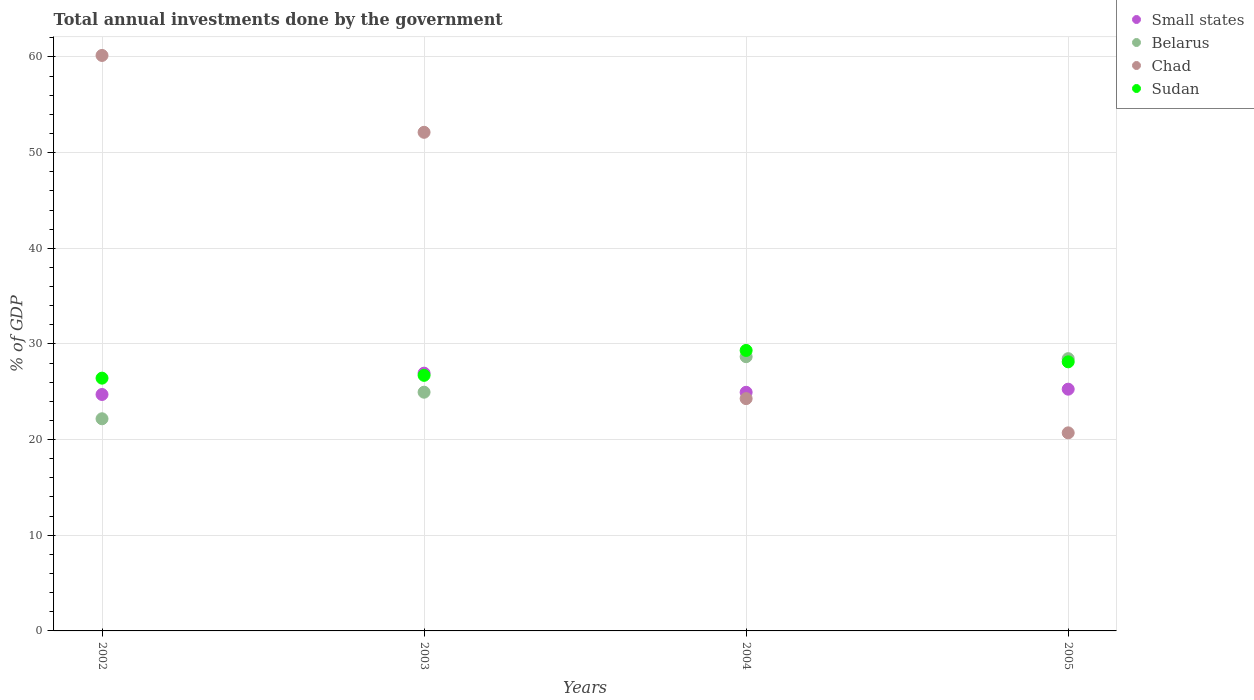How many different coloured dotlines are there?
Give a very brief answer. 4. What is the total annual investments done by the government in Chad in 2005?
Make the answer very short. 20.7. Across all years, what is the maximum total annual investments done by the government in Small states?
Offer a very short reply. 26.95. Across all years, what is the minimum total annual investments done by the government in Belarus?
Offer a very short reply. 22.18. In which year was the total annual investments done by the government in Small states minimum?
Keep it short and to the point. 2002. What is the total total annual investments done by the government in Small states in the graph?
Make the answer very short. 101.88. What is the difference between the total annual investments done by the government in Sudan in 2002 and that in 2004?
Provide a succinct answer. -2.9. What is the difference between the total annual investments done by the government in Chad in 2002 and the total annual investments done by the government in Sudan in 2003?
Provide a short and direct response. 33.44. What is the average total annual investments done by the government in Small states per year?
Provide a short and direct response. 25.47. In the year 2004, what is the difference between the total annual investments done by the government in Chad and total annual investments done by the government in Sudan?
Ensure brevity in your answer.  -5.04. In how many years, is the total annual investments done by the government in Chad greater than 44 %?
Provide a succinct answer. 2. What is the ratio of the total annual investments done by the government in Chad in 2002 to that in 2005?
Make the answer very short. 2.91. What is the difference between the highest and the second highest total annual investments done by the government in Small states?
Ensure brevity in your answer.  1.67. What is the difference between the highest and the lowest total annual investments done by the government in Chad?
Give a very brief answer. 39.45. Is the sum of the total annual investments done by the government in Belarus in 2002 and 2005 greater than the maximum total annual investments done by the government in Chad across all years?
Give a very brief answer. No. Does the total annual investments done by the government in Belarus monotonically increase over the years?
Make the answer very short. No. Is the total annual investments done by the government in Chad strictly greater than the total annual investments done by the government in Belarus over the years?
Keep it short and to the point. No. How many dotlines are there?
Keep it short and to the point. 4. Are the values on the major ticks of Y-axis written in scientific E-notation?
Offer a terse response. No. Does the graph contain grids?
Offer a very short reply. Yes. How many legend labels are there?
Your answer should be compact. 4. How are the legend labels stacked?
Offer a very short reply. Vertical. What is the title of the graph?
Give a very brief answer. Total annual investments done by the government. What is the label or title of the Y-axis?
Offer a very short reply. % of GDP. What is the % of GDP in Small states in 2002?
Ensure brevity in your answer.  24.72. What is the % of GDP in Belarus in 2002?
Provide a short and direct response. 22.18. What is the % of GDP of Chad in 2002?
Offer a terse response. 60.16. What is the % of GDP in Sudan in 2002?
Make the answer very short. 26.42. What is the % of GDP in Small states in 2003?
Provide a short and direct response. 26.95. What is the % of GDP of Belarus in 2003?
Ensure brevity in your answer.  24.95. What is the % of GDP in Chad in 2003?
Offer a terse response. 52.12. What is the % of GDP in Sudan in 2003?
Provide a short and direct response. 26.71. What is the % of GDP in Small states in 2004?
Give a very brief answer. 24.94. What is the % of GDP in Belarus in 2004?
Your answer should be compact. 28.67. What is the % of GDP of Chad in 2004?
Make the answer very short. 24.28. What is the % of GDP of Sudan in 2004?
Your answer should be compact. 29.32. What is the % of GDP of Small states in 2005?
Keep it short and to the point. 25.27. What is the % of GDP in Belarus in 2005?
Give a very brief answer. 28.46. What is the % of GDP of Chad in 2005?
Your response must be concise. 20.7. What is the % of GDP of Sudan in 2005?
Keep it short and to the point. 28.13. Across all years, what is the maximum % of GDP in Small states?
Provide a short and direct response. 26.95. Across all years, what is the maximum % of GDP of Belarus?
Provide a short and direct response. 28.67. Across all years, what is the maximum % of GDP of Chad?
Offer a very short reply. 60.16. Across all years, what is the maximum % of GDP in Sudan?
Give a very brief answer. 29.32. Across all years, what is the minimum % of GDP in Small states?
Keep it short and to the point. 24.72. Across all years, what is the minimum % of GDP of Belarus?
Offer a terse response. 22.18. Across all years, what is the minimum % of GDP of Chad?
Give a very brief answer. 20.7. Across all years, what is the minimum % of GDP of Sudan?
Your answer should be compact. 26.42. What is the total % of GDP in Small states in the graph?
Give a very brief answer. 101.88. What is the total % of GDP of Belarus in the graph?
Your answer should be compact. 104.26. What is the total % of GDP of Chad in the graph?
Ensure brevity in your answer.  157.27. What is the total % of GDP in Sudan in the graph?
Your answer should be very brief. 110.59. What is the difference between the % of GDP of Small states in 2002 and that in 2003?
Make the answer very short. -2.23. What is the difference between the % of GDP of Belarus in 2002 and that in 2003?
Provide a short and direct response. -2.78. What is the difference between the % of GDP of Chad in 2002 and that in 2003?
Make the answer very short. 8.03. What is the difference between the % of GDP in Sudan in 2002 and that in 2003?
Provide a succinct answer. -0.29. What is the difference between the % of GDP in Small states in 2002 and that in 2004?
Your answer should be very brief. -0.23. What is the difference between the % of GDP in Belarus in 2002 and that in 2004?
Your answer should be compact. -6.49. What is the difference between the % of GDP of Chad in 2002 and that in 2004?
Offer a terse response. 35.87. What is the difference between the % of GDP of Sudan in 2002 and that in 2004?
Your answer should be compact. -2.9. What is the difference between the % of GDP in Small states in 2002 and that in 2005?
Ensure brevity in your answer.  -0.55. What is the difference between the % of GDP in Belarus in 2002 and that in 2005?
Ensure brevity in your answer.  -6.28. What is the difference between the % of GDP in Chad in 2002 and that in 2005?
Your answer should be very brief. 39.45. What is the difference between the % of GDP in Sudan in 2002 and that in 2005?
Your answer should be compact. -1.71. What is the difference between the % of GDP of Small states in 2003 and that in 2004?
Keep it short and to the point. 2. What is the difference between the % of GDP in Belarus in 2003 and that in 2004?
Give a very brief answer. -3.71. What is the difference between the % of GDP of Chad in 2003 and that in 2004?
Give a very brief answer. 27.84. What is the difference between the % of GDP of Sudan in 2003 and that in 2004?
Offer a very short reply. -2.61. What is the difference between the % of GDP in Small states in 2003 and that in 2005?
Your answer should be very brief. 1.67. What is the difference between the % of GDP in Belarus in 2003 and that in 2005?
Ensure brevity in your answer.  -3.51. What is the difference between the % of GDP of Chad in 2003 and that in 2005?
Offer a very short reply. 31.42. What is the difference between the % of GDP in Sudan in 2003 and that in 2005?
Offer a terse response. -1.41. What is the difference between the % of GDP in Small states in 2004 and that in 2005?
Ensure brevity in your answer.  -0.33. What is the difference between the % of GDP in Belarus in 2004 and that in 2005?
Offer a terse response. 0.21. What is the difference between the % of GDP of Chad in 2004 and that in 2005?
Make the answer very short. 3.58. What is the difference between the % of GDP of Sudan in 2004 and that in 2005?
Offer a very short reply. 1.19. What is the difference between the % of GDP in Small states in 2002 and the % of GDP in Belarus in 2003?
Provide a short and direct response. -0.24. What is the difference between the % of GDP in Small states in 2002 and the % of GDP in Chad in 2003?
Offer a terse response. -27.41. What is the difference between the % of GDP in Small states in 2002 and the % of GDP in Sudan in 2003?
Your answer should be very brief. -2. What is the difference between the % of GDP in Belarus in 2002 and the % of GDP in Chad in 2003?
Make the answer very short. -29.94. What is the difference between the % of GDP in Belarus in 2002 and the % of GDP in Sudan in 2003?
Ensure brevity in your answer.  -4.54. What is the difference between the % of GDP in Chad in 2002 and the % of GDP in Sudan in 2003?
Your response must be concise. 33.44. What is the difference between the % of GDP of Small states in 2002 and the % of GDP of Belarus in 2004?
Provide a succinct answer. -3.95. What is the difference between the % of GDP in Small states in 2002 and the % of GDP in Chad in 2004?
Make the answer very short. 0.43. What is the difference between the % of GDP in Small states in 2002 and the % of GDP in Sudan in 2004?
Give a very brief answer. -4.6. What is the difference between the % of GDP in Belarus in 2002 and the % of GDP in Chad in 2004?
Provide a short and direct response. -2.11. What is the difference between the % of GDP in Belarus in 2002 and the % of GDP in Sudan in 2004?
Your answer should be very brief. -7.14. What is the difference between the % of GDP in Chad in 2002 and the % of GDP in Sudan in 2004?
Offer a very short reply. 30.84. What is the difference between the % of GDP in Small states in 2002 and the % of GDP in Belarus in 2005?
Your answer should be very brief. -3.74. What is the difference between the % of GDP in Small states in 2002 and the % of GDP in Chad in 2005?
Keep it short and to the point. 4.01. What is the difference between the % of GDP in Small states in 2002 and the % of GDP in Sudan in 2005?
Keep it short and to the point. -3.41. What is the difference between the % of GDP in Belarus in 2002 and the % of GDP in Chad in 2005?
Offer a terse response. 1.47. What is the difference between the % of GDP in Belarus in 2002 and the % of GDP in Sudan in 2005?
Give a very brief answer. -5.95. What is the difference between the % of GDP of Chad in 2002 and the % of GDP of Sudan in 2005?
Give a very brief answer. 32.03. What is the difference between the % of GDP of Small states in 2003 and the % of GDP of Belarus in 2004?
Make the answer very short. -1.72. What is the difference between the % of GDP of Small states in 2003 and the % of GDP of Chad in 2004?
Keep it short and to the point. 2.66. What is the difference between the % of GDP of Small states in 2003 and the % of GDP of Sudan in 2004?
Your answer should be compact. -2.38. What is the difference between the % of GDP of Belarus in 2003 and the % of GDP of Chad in 2004?
Your answer should be compact. 0.67. What is the difference between the % of GDP of Belarus in 2003 and the % of GDP of Sudan in 2004?
Provide a short and direct response. -4.37. What is the difference between the % of GDP of Chad in 2003 and the % of GDP of Sudan in 2004?
Provide a short and direct response. 22.8. What is the difference between the % of GDP of Small states in 2003 and the % of GDP of Belarus in 2005?
Your answer should be compact. -1.52. What is the difference between the % of GDP of Small states in 2003 and the % of GDP of Chad in 2005?
Ensure brevity in your answer.  6.24. What is the difference between the % of GDP in Small states in 2003 and the % of GDP in Sudan in 2005?
Your answer should be compact. -1.18. What is the difference between the % of GDP of Belarus in 2003 and the % of GDP of Chad in 2005?
Offer a very short reply. 4.25. What is the difference between the % of GDP of Belarus in 2003 and the % of GDP of Sudan in 2005?
Your response must be concise. -3.17. What is the difference between the % of GDP in Chad in 2003 and the % of GDP in Sudan in 2005?
Make the answer very short. 23.99. What is the difference between the % of GDP in Small states in 2004 and the % of GDP in Belarus in 2005?
Provide a short and direct response. -3.52. What is the difference between the % of GDP in Small states in 2004 and the % of GDP in Chad in 2005?
Your response must be concise. 4.24. What is the difference between the % of GDP in Small states in 2004 and the % of GDP in Sudan in 2005?
Your answer should be compact. -3.18. What is the difference between the % of GDP of Belarus in 2004 and the % of GDP of Chad in 2005?
Provide a succinct answer. 7.96. What is the difference between the % of GDP of Belarus in 2004 and the % of GDP of Sudan in 2005?
Make the answer very short. 0.54. What is the difference between the % of GDP of Chad in 2004 and the % of GDP of Sudan in 2005?
Your answer should be compact. -3.84. What is the average % of GDP of Small states per year?
Ensure brevity in your answer.  25.47. What is the average % of GDP in Belarus per year?
Make the answer very short. 26.06. What is the average % of GDP in Chad per year?
Keep it short and to the point. 39.32. What is the average % of GDP in Sudan per year?
Provide a succinct answer. 27.65. In the year 2002, what is the difference between the % of GDP in Small states and % of GDP in Belarus?
Your answer should be compact. 2.54. In the year 2002, what is the difference between the % of GDP in Small states and % of GDP in Chad?
Make the answer very short. -35.44. In the year 2002, what is the difference between the % of GDP of Small states and % of GDP of Sudan?
Your answer should be compact. -1.71. In the year 2002, what is the difference between the % of GDP in Belarus and % of GDP in Chad?
Make the answer very short. -37.98. In the year 2002, what is the difference between the % of GDP in Belarus and % of GDP in Sudan?
Provide a succinct answer. -4.25. In the year 2002, what is the difference between the % of GDP in Chad and % of GDP in Sudan?
Your answer should be compact. 33.73. In the year 2003, what is the difference between the % of GDP of Small states and % of GDP of Belarus?
Give a very brief answer. 1.99. In the year 2003, what is the difference between the % of GDP of Small states and % of GDP of Chad?
Give a very brief answer. -25.18. In the year 2003, what is the difference between the % of GDP in Small states and % of GDP in Sudan?
Keep it short and to the point. 0.23. In the year 2003, what is the difference between the % of GDP of Belarus and % of GDP of Chad?
Keep it short and to the point. -27.17. In the year 2003, what is the difference between the % of GDP of Belarus and % of GDP of Sudan?
Provide a short and direct response. -1.76. In the year 2003, what is the difference between the % of GDP in Chad and % of GDP in Sudan?
Ensure brevity in your answer.  25.41. In the year 2004, what is the difference between the % of GDP in Small states and % of GDP in Belarus?
Provide a short and direct response. -3.72. In the year 2004, what is the difference between the % of GDP of Small states and % of GDP of Chad?
Give a very brief answer. 0.66. In the year 2004, what is the difference between the % of GDP of Small states and % of GDP of Sudan?
Your answer should be very brief. -4.38. In the year 2004, what is the difference between the % of GDP of Belarus and % of GDP of Chad?
Offer a very short reply. 4.38. In the year 2004, what is the difference between the % of GDP in Belarus and % of GDP in Sudan?
Ensure brevity in your answer.  -0.65. In the year 2004, what is the difference between the % of GDP of Chad and % of GDP of Sudan?
Provide a succinct answer. -5.04. In the year 2005, what is the difference between the % of GDP of Small states and % of GDP of Belarus?
Offer a very short reply. -3.19. In the year 2005, what is the difference between the % of GDP in Small states and % of GDP in Chad?
Keep it short and to the point. 4.57. In the year 2005, what is the difference between the % of GDP in Small states and % of GDP in Sudan?
Your answer should be compact. -2.86. In the year 2005, what is the difference between the % of GDP of Belarus and % of GDP of Chad?
Give a very brief answer. 7.76. In the year 2005, what is the difference between the % of GDP in Belarus and % of GDP in Sudan?
Provide a succinct answer. 0.33. In the year 2005, what is the difference between the % of GDP of Chad and % of GDP of Sudan?
Provide a short and direct response. -7.42. What is the ratio of the % of GDP in Small states in 2002 to that in 2003?
Your response must be concise. 0.92. What is the ratio of the % of GDP in Belarus in 2002 to that in 2003?
Your response must be concise. 0.89. What is the ratio of the % of GDP in Chad in 2002 to that in 2003?
Your answer should be compact. 1.15. What is the ratio of the % of GDP of Sudan in 2002 to that in 2003?
Offer a terse response. 0.99. What is the ratio of the % of GDP of Small states in 2002 to that in 2004?
Make the answer very short. 0.99. What is the ratio of the % of GDP in Belarus in 2002 to that in 2004?
Provide a succinct answer. 0.77. What is the ratio of the % of GDP of Chad in 2002 to that in 2004?
Your answer should be very brief. 2.48. What is the ratio of the % of GDP of Sudan in 2002 to that in 2004?
Your answer should be very brief. 0.9. What is the ratio of the % of GDP of Belarus in 2002 to that in 2005?
Keep it short and to the point. 0.78. What is the ratio of the % of GDP of Chad in 2002 to that in 2005?
Your answer should be very brief. 2.91. What is the ratio of the % of GDP of Sudan in 2002 to that in 2005?
Give a very brief answer. 0.94. What is the ratio of the % of GDP in Small states in 2003 to that in 2004?
Offer a very short reply. 1.08. What is the ratio of the % of GDP in Belarus in 2003 to that in 2004?
Keep it short and to the point. 0.87. What is the ratio of the % of GDP in Chad in 2003 to that in 2004?
Keep it short and to the point. 2.15. What is the ratio of the % of GDP of Sudan in 2003 to that in 2004?
Offer a very short reply. 0.91. What is the ratio of the % of GDP in Small states in 2003 to that in 2005?
Provide a succinct answer. 1.07. What is the ratio of the % of GDP in Belarus in 2003 to that in 2005?
Your response must be concise. 0.88. What is the ratio of the % of GDP of Chad in 2003 to that in 2005?
Your response must be concise. 2.52. What is the ratio of the % of GDP in Sudan in 2003 to that in 2005?
Provide a short and direct response. 0.95. What is the ratio of the % of GDP in Small states in 2004 to that in 2005?
Make the answer very short. 0.99. What is the ratio of the % of GDP of Belarus in 2004 to that in 2005?
Provide a short and direct response. 1.01. What is the ratio of the % of GDP of Chad in 2004 to that in 2005?
Make the answer very short. 1.17. What is the ratio of the % of GDP in Sudan in 2004 to that in 2005?
Offer a terse response. 1.04. What is the difference between the highest and the second highest % of GDP in Small states?
Your response must be concise. 1.67. What is the difference between the highest and the second highest % of GDP in Belarus?
Offer a very short reply. 0.21. What is the difference between the highest and the second highest % of GDP in Chad?
Provide a short and direct response. 8.03. What is the difference between the highest and the second highest % of GDP in Sudan?
Your response must be concise. 1.19. What is the difference between the highest and the lowest % of GDP of Small states?
Your answer should be very brief. 2.23. What is the difference between the highest and the lowest % of GDP in Belarus?
Offer a terse response. 6.49. What is the difference between the highest and the lowest % of GDP of Chad?
Ensure brevity in your answer.  39.45. What is the difference between the highest and the lowest % of GDP of Sudan?
Your answer should be very brief. 2.9. 